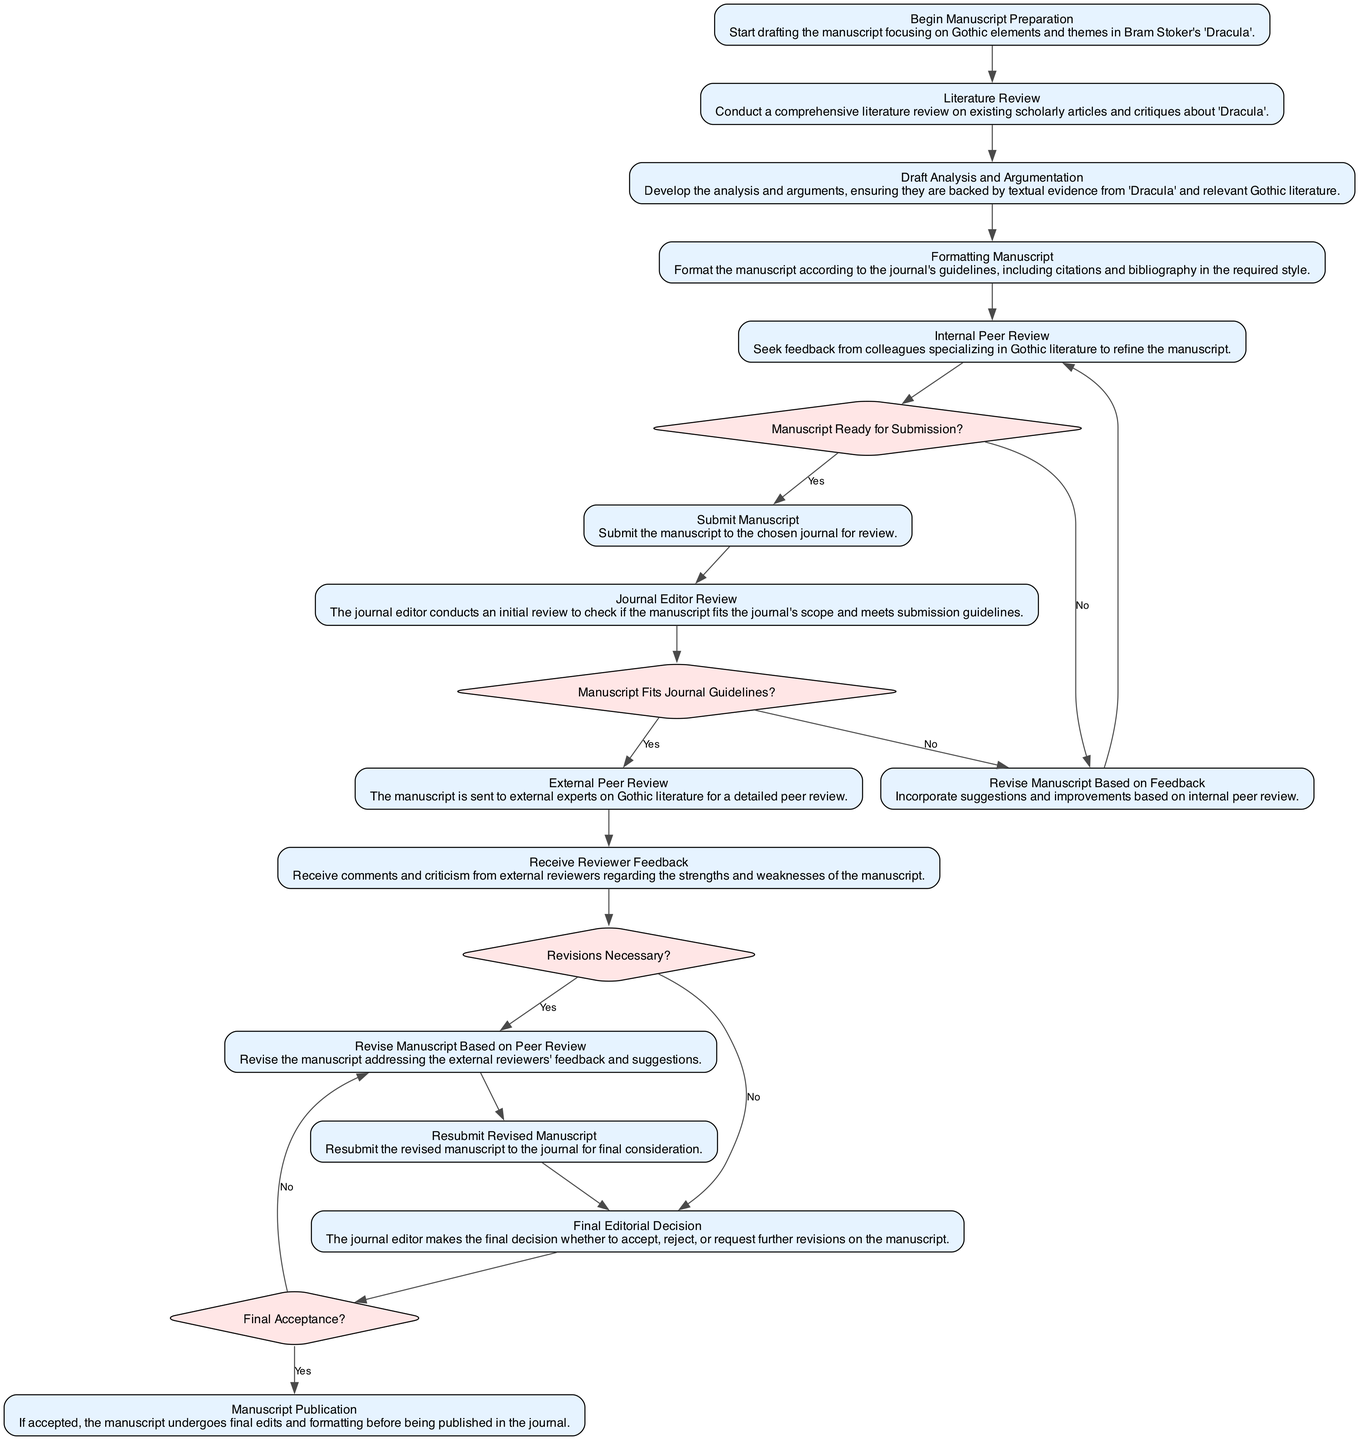What is the first activity in the manuscript process? The first activity listed in the diagram is “Begin Manuscript Preparation,” which indicates the starting point of the process.
Answer: Begin Manuscript Preparation How many decisions are included in the diagram? By counting the decision nodes labeled “Manuscript Ready for Submission?”, “Manuscript Fits Journal Guidelines?”, “Revisions Necessary?”, and “Final Acceptance?”, we find there are four decision nodes present in the diagram.
Answer: 4 What happens if the manuscript is not ready for submission after internal peer review? Following the decision labeled “Manuscript Ready for Submission?”, if the answer is “No,” the process flows to “Revise Manuscript Based on Feedback,” indicating that revisions must be made before submission.
Answer: Revise Manuscript Based on Feedback What happens after "Receive Reviewer Feedback"? From the node labeled “Receive Reviewer Feedback,” the next step is the decision labeled “Revisions Necessary?”, which determines if further revisions are required or if the process can move to the final editorial decision.
Answer: Revisions Necessary? If the manuscript is accepted after resubmission, what is the next activity? After the decision “Final Acceptance?” if the answer is “Yes,” the flow leads to “Manuscript Publication,” which indicates that the accepted manuscript will go through final edits and be published.
Answer: Manuscript Publication What is the last activity in the manuscript process? The final activity depicted in the diagram is “Manuscript Publication,” marking the completion of the manuscript review and submission process.
Answer: Manuscript Publication What is the outcome if the manuscript does not fit journal guidelines? If the journal editor determines that the manuscript does not fit the journal guidelines, the process leads to “Revise Manuscript Based on Feedback,” meaning that revisions need to be made before resubmission.
Answer: Revise Manuscript Based on Feedback How does the process flow after drafting the analysis and argumentation? After “Draft Analysis and Argumentation,” the next step is “Formatting Manuscript,” indicating that proper formatting must be applied before internal peer review.
Answer: Formatting Manuscript 